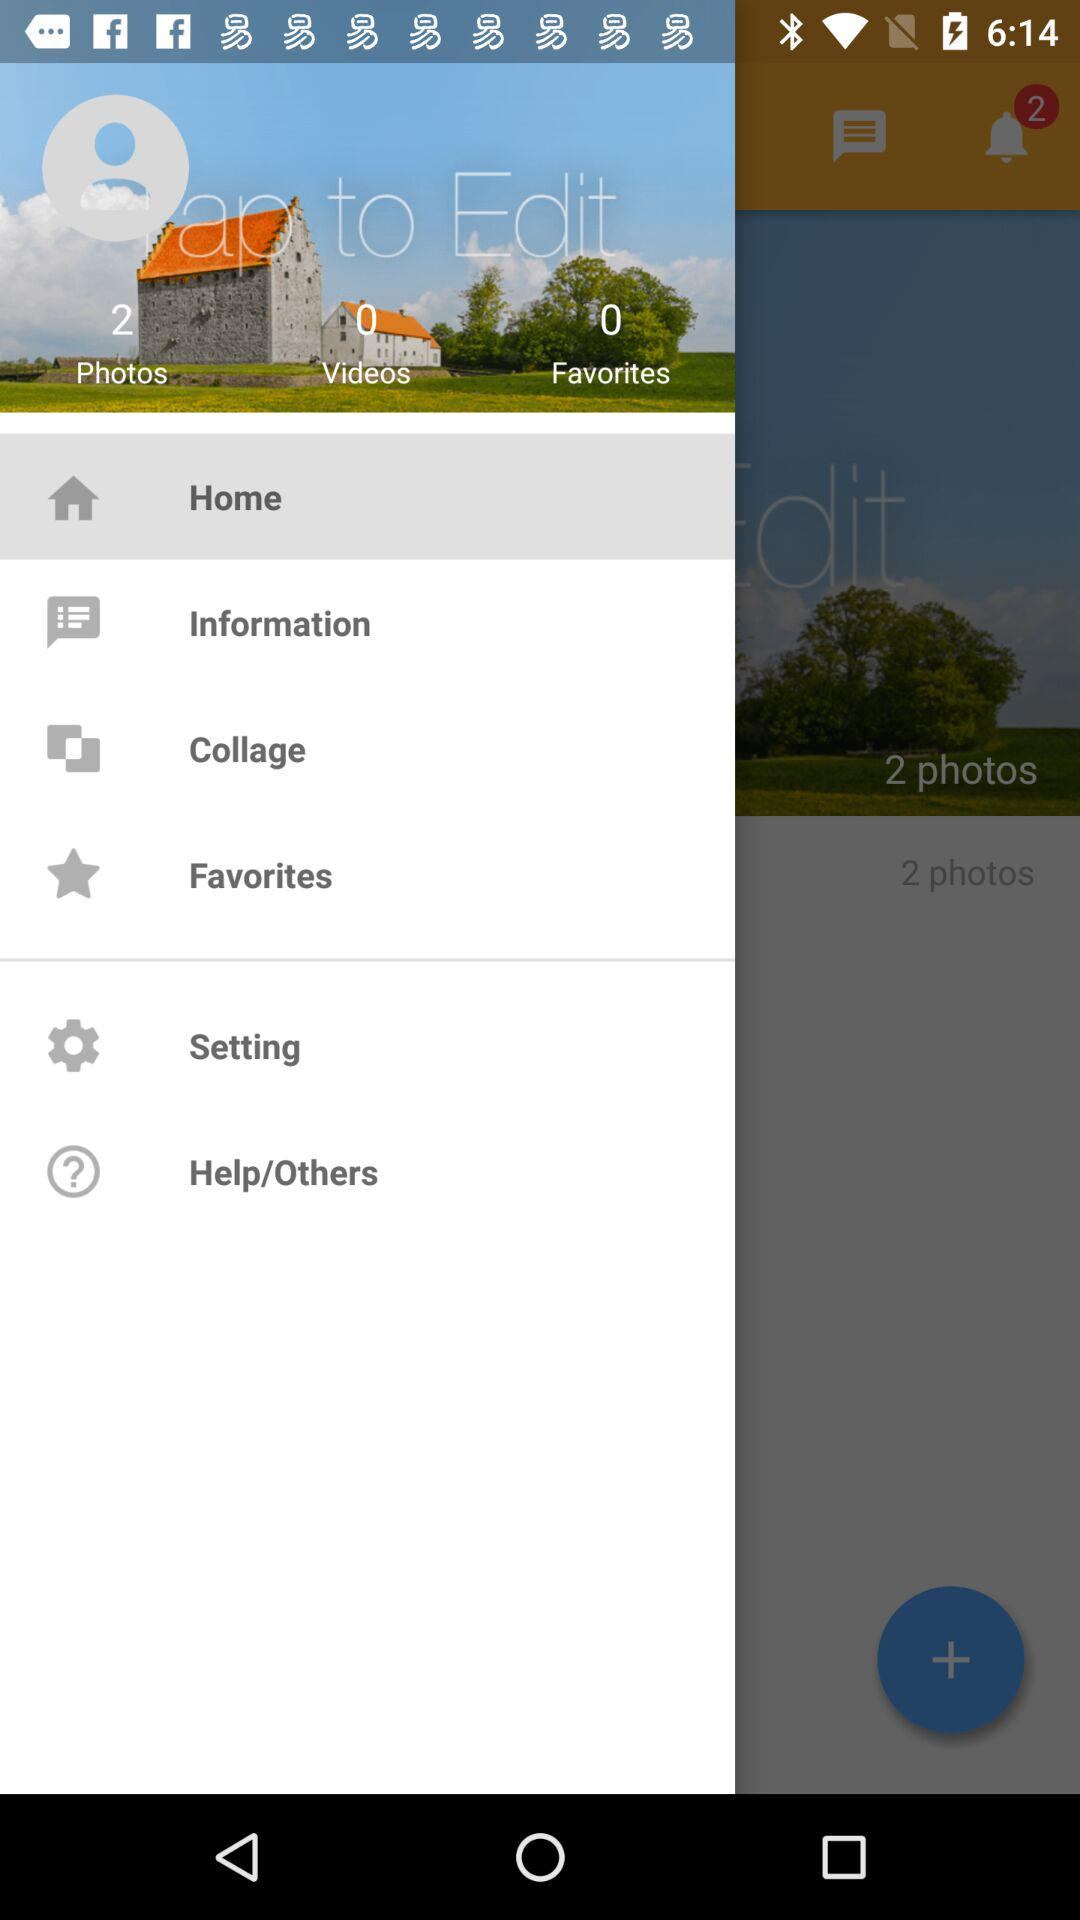How many photos are there? There are 2 photos. 